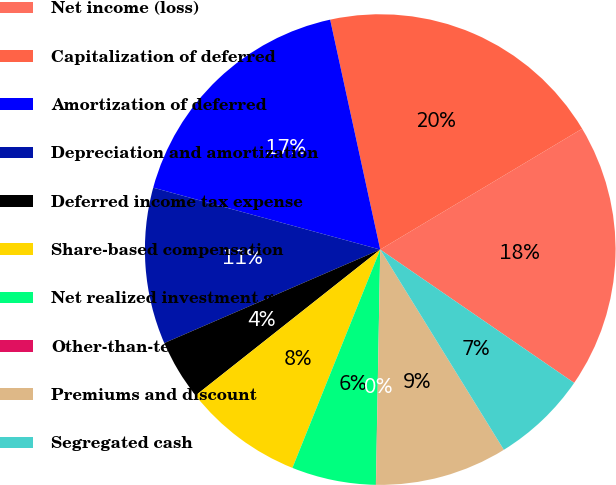Convert chart. <chart><loc_0><loc_0><loc_500><loc_500><pie_chart><fcel>Net income (loss)<fcel>Capitalization of deferred<fcel>Amortization of deferred<fcel>Depreciation and amortization<fcel>Deferred income tax expense<fcel>Share-based compensation<fcel>Net realized investment gains<fcel>Other-than-temporary<fcel>Premiums and discount<fcel>Segregated cash<nl><fcel>18.17%<fcel>19.83%<fcel>17.35%<fcel>10.74%<fcel>4.14%<fcel>8.27%<fcel>5.79%<fcel>0.01%<fcel>9.09%<fcel>6.61%<nl></chart> 